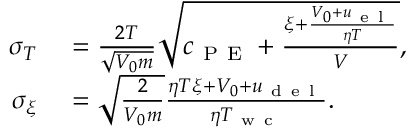Convert formula to latex. <formula><loc_0><loc_0><loc_500><loc_500>\begin{array} { r l } { \sigma _ { T } } & = \frac { 2 T } { \sqrt { V _ { 0 } m } } \sqrt { c _ { P E } + \frac { \xi + \frac { V _ { 0 } + u _ { e l } } { \eta T } } { V } } , } \\ { \sigma _ { \xi } } & = \sqrt { \frac { 2 } { V _ { 0 } m } } \frac { \eta T \xi + V _ { 0 } + u _ { d e l } } { \eta T _ { w c } } . } \end{array}</formula> 